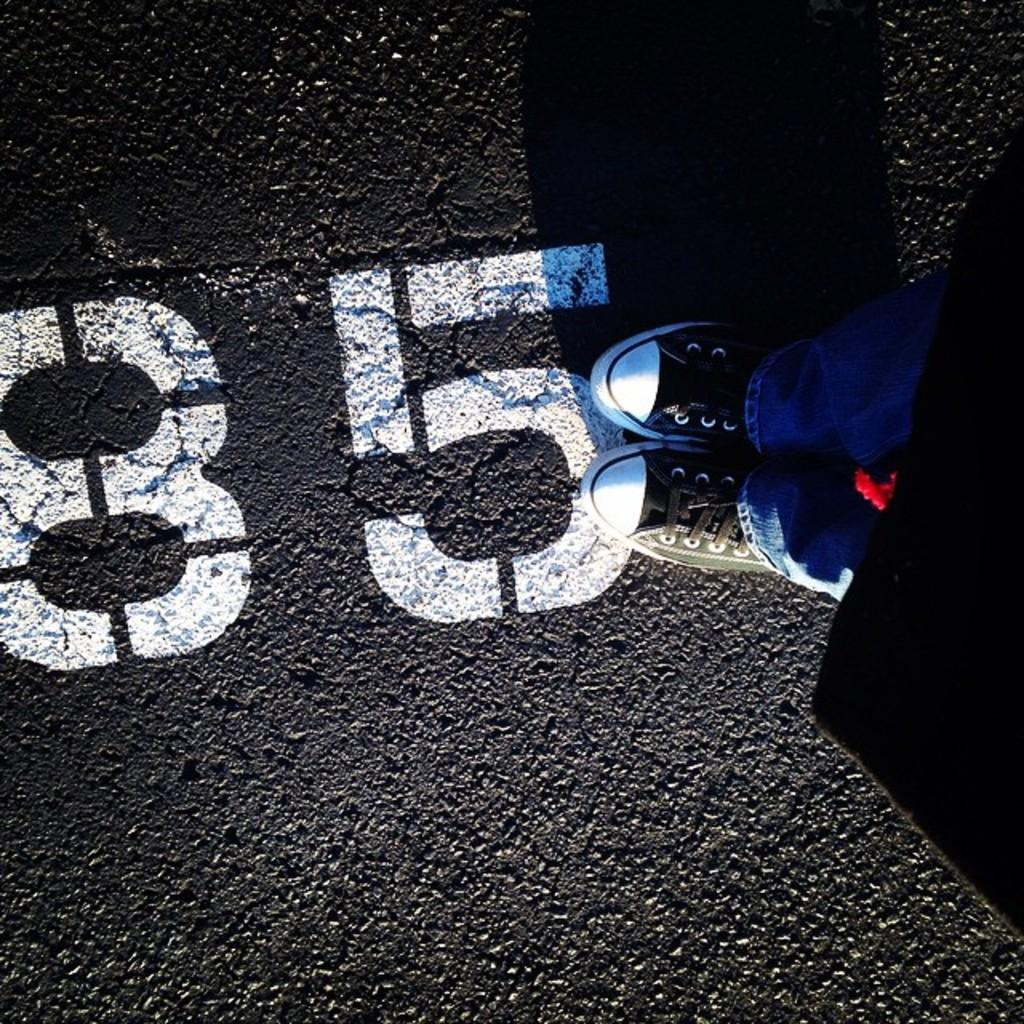What can be seen written on the road in the image? There are numbers written on the road in the image. Can you describe anything else visible in the image? The legs of a person wearing shoes are visible on the right side of the image. What type of committee is meeting on the road in the image? There is no committee meeting on the road in the image; it only shows numbers written on the road and the legs of a person wearing shoes. What kind of celery can be seen growing on the side of the road in the image? There is no celery present in the image; it only shows numbers written on the road and the legs of a person wearing shoes. 